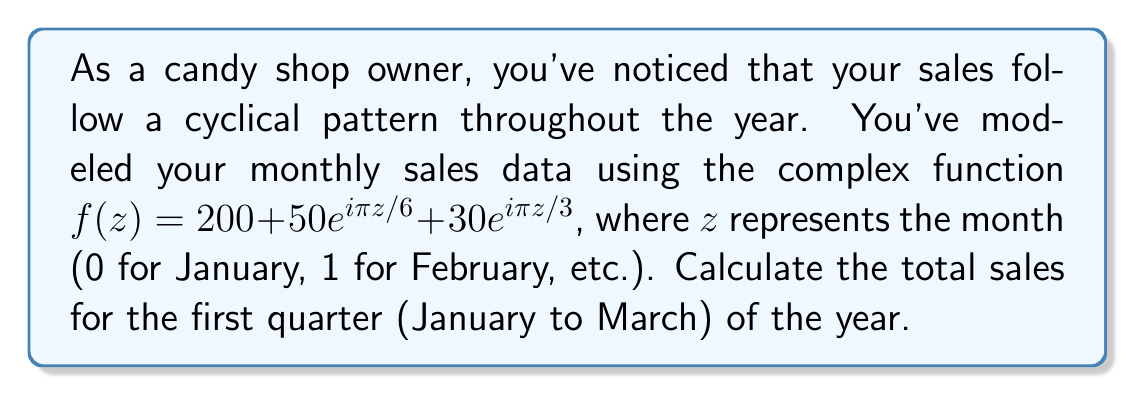Teach me how to tackle this problem. To solve this problem, we need to follow these steps:

1) The given function is $f(z) = 200 + 50e^{i\pi z/6} + 30e^{i\pi z/3}$

2) We need to calculate the sales for January (z=0), February (z=1), and March (z=2)

3) For January (z=0):
   $f(0) = 200 + 50e^{i\pi(0)/6} + 30e^{i\pi(0)/3}$
   $= 200 + 50 + 30 = 280$

4) For February (z=1):
   $f(1) = 200 + 50e^{i\pi/6} + 30e^{i\pi/3}$
   $= 200 + 50(\cos(\pi/6) + i\sin(\pi/6)) + 30(\cos(\pi/3) + i\sin(\pi/3))$
   $= 200 + 50(\sqrt{3}/2 + i/2) + 30(1/2 + i\sqrt{3}/2)$
   $= 200 + 43.30 + i25 + 15 + i25.98$
   $= 258.30 + i50.98$
   The real part, 258.30, represents the sales for February.

5) For March (z=2):
   $f(2) = 200 + 50e^{i\pi/3} + 30e^{2i\pi/3}$
   $= 200 + 50(\cos(\pi/3) + i\sin(\pi/3)) + 30(\cos(2\pi/3) + i\sin(2\pi/3))$
   $= 200 + 50(1/2 + i\sqrt{3}/2) + 30(-1/2 + i\sqrt{3}/2)$
   $= 200 + 25 + i43.30 - 15 + i25.98$
   $= 210 + i69.28$
   The real part, 210, represents the sales for March.

6) Total sales for the first quarter = January + February + March
   $= 280 + 258.30 + 210 = 748.30$
Answer: The total sales for the first quarter is $748.30. 